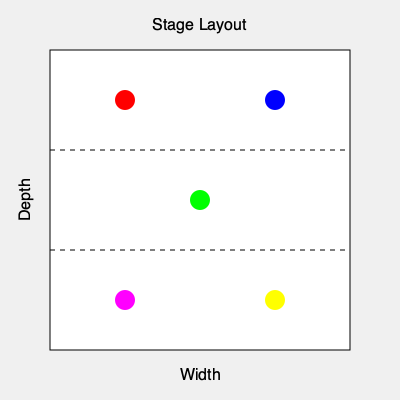In a music video choreography for a 5-member idol group, you need to design a formation change that maximizes stage coverage and visual appeal. Given the stage layout shown, with dancers represented by colored circles, calculate the total distance traveled by all members if they move to form a perfect pentagon with a side length of 100 units. Assume the stage is 300 units wide and 300 units deep, and the initial positions are as shown. Round your answer to the nearest whole number. To solve this problem, we'll follow these steps:

1. Identify the initial positions of the dancers:
   Red (125, 100), Blue (275, 100), Green (200, 200), Magenta (125, 300), Yellow (275, 300)

2. Calculate the center of the stage:
   Center = (200, 200)

3. Calculate the positions of a perfect pentagon with side length 100 units, centered at (200, 200):
   Let $r$ be the radius of the circumscribed circle of the pentagon.
   $r = \frac{100}{2\sin(\frac{360°}{5\cdot2})} \approx 85.065$

   Pentagon vertices (approximate):
   P1 = (200 + r*cos(90°), 200 - r*sin(90°)) ≈ (200, 115)
   P2 = (200 + r*cos(18°), 200 - r*sin(18°)) ≈ (281, 174)
   P3 = (200 + r*cos(-54°), 200 - r*sin(-54°)) ≈ (251, 272)
   P4 = (200 + r*cos(-126°), 200 - r*sin(-126°)) ≈ (149, 272)
   P5 = (200 + r*cos(-198°), 200 - r*sin(-198°)) ≈ (119, 174)

4. Calculate the distance each dancer needs to travel:
   Red to P5: $\sqrt{(119-125)^2 + (174-100)^2} \approx 74.27$
   Blue to P2: $\sqrt{(281-275)^2 + (174-100)^2} \approx 74.27$
   Green to P1: $\sqrt{(200-200)^2 + (115-200)^2} = 85$
   Magenta to P4: $\sqrt{(149-125)^2 + (272-300)^2} \approx 38.28$
   Yellow to P3: $\sqrt{(251-275)^2 + (272-300)^2} \approx 38.28$

5. Sum up all the distances:
   Total distance = 74.27 + 74.27 + 85 + 38.28 + 38.28 = 310.1

6. Round to the nearest whole number:
   310
Answer: 310 units 